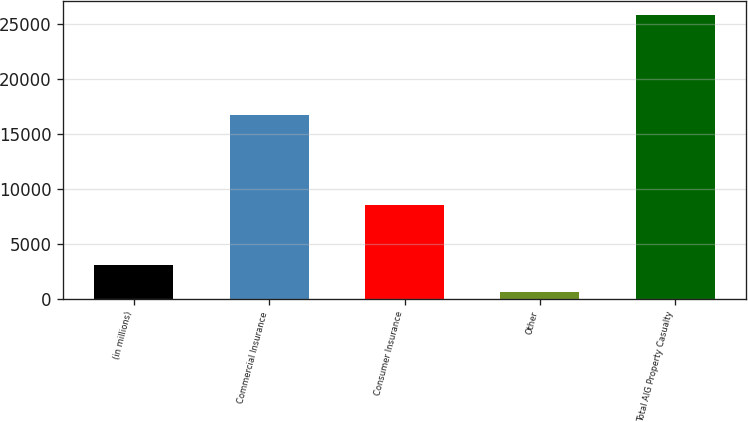Convert chart to OTSL. <chart><loc_0><loc_0><loc_500><loc_500><bar_chart><fcel>(in millions)<fcel>Commercial Insurance<fcel>Consumer Insurance<fcel>Other<fcel>Total AIG Property Casualty<nl><fcel>3110.4<fcel>16696<fcel>8498<fcel>591<fcel>25785<nl></chart> 